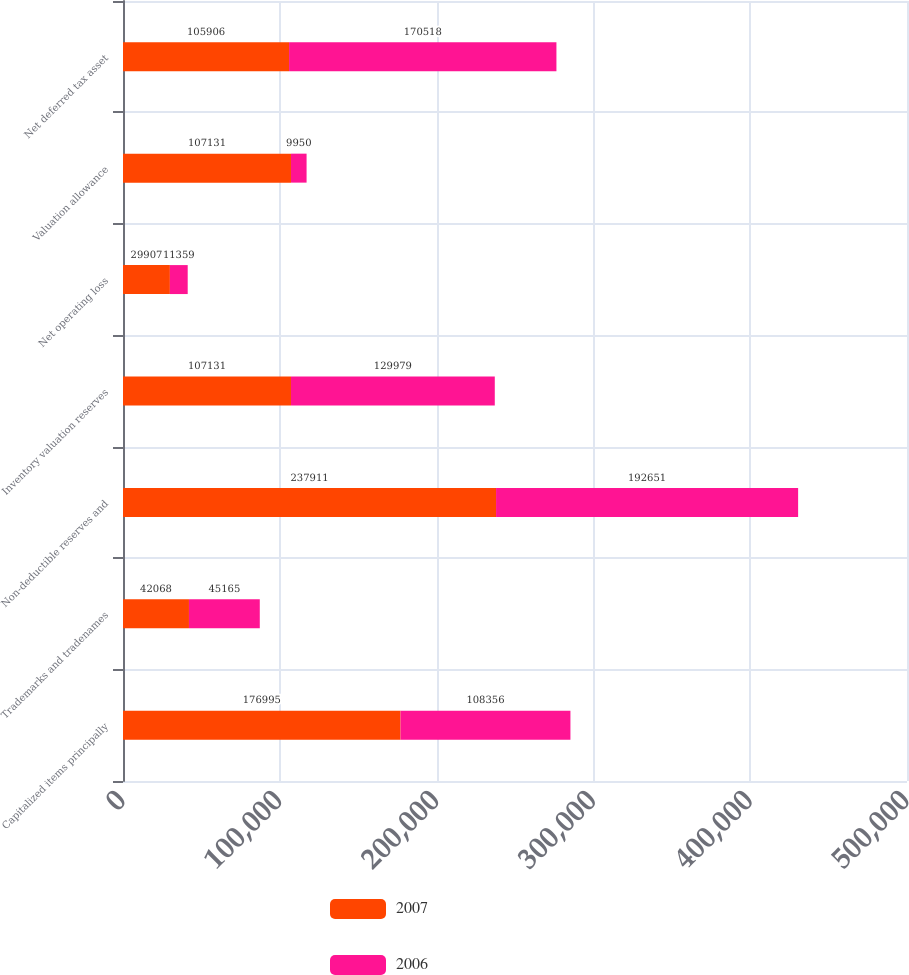Convert chart. <chart><loc_0><loc_0><loc_500><loc_500><stacked_bar_chart><ecel><fcel>Capitalized items principally<fcel>Trademarks and tradenames<fcel>Non-deductible reserves and<fcel>Inventory valuation reserves<fcel>Net operating loss<fcel>Valuation allowance<fcel>Net deferred tax asset<nl><fcel>2007<fcel>176995<fcel>42068<fcel>237911<fcel>107131<fcel>29907<fcel>107131<fcel>105906<nl><fcel>2006<fcel>108356<fcel>45165<fcel>192651<fcel>129979<fcel>11359<fcel>9950<fcel>170518<nl></chart> 